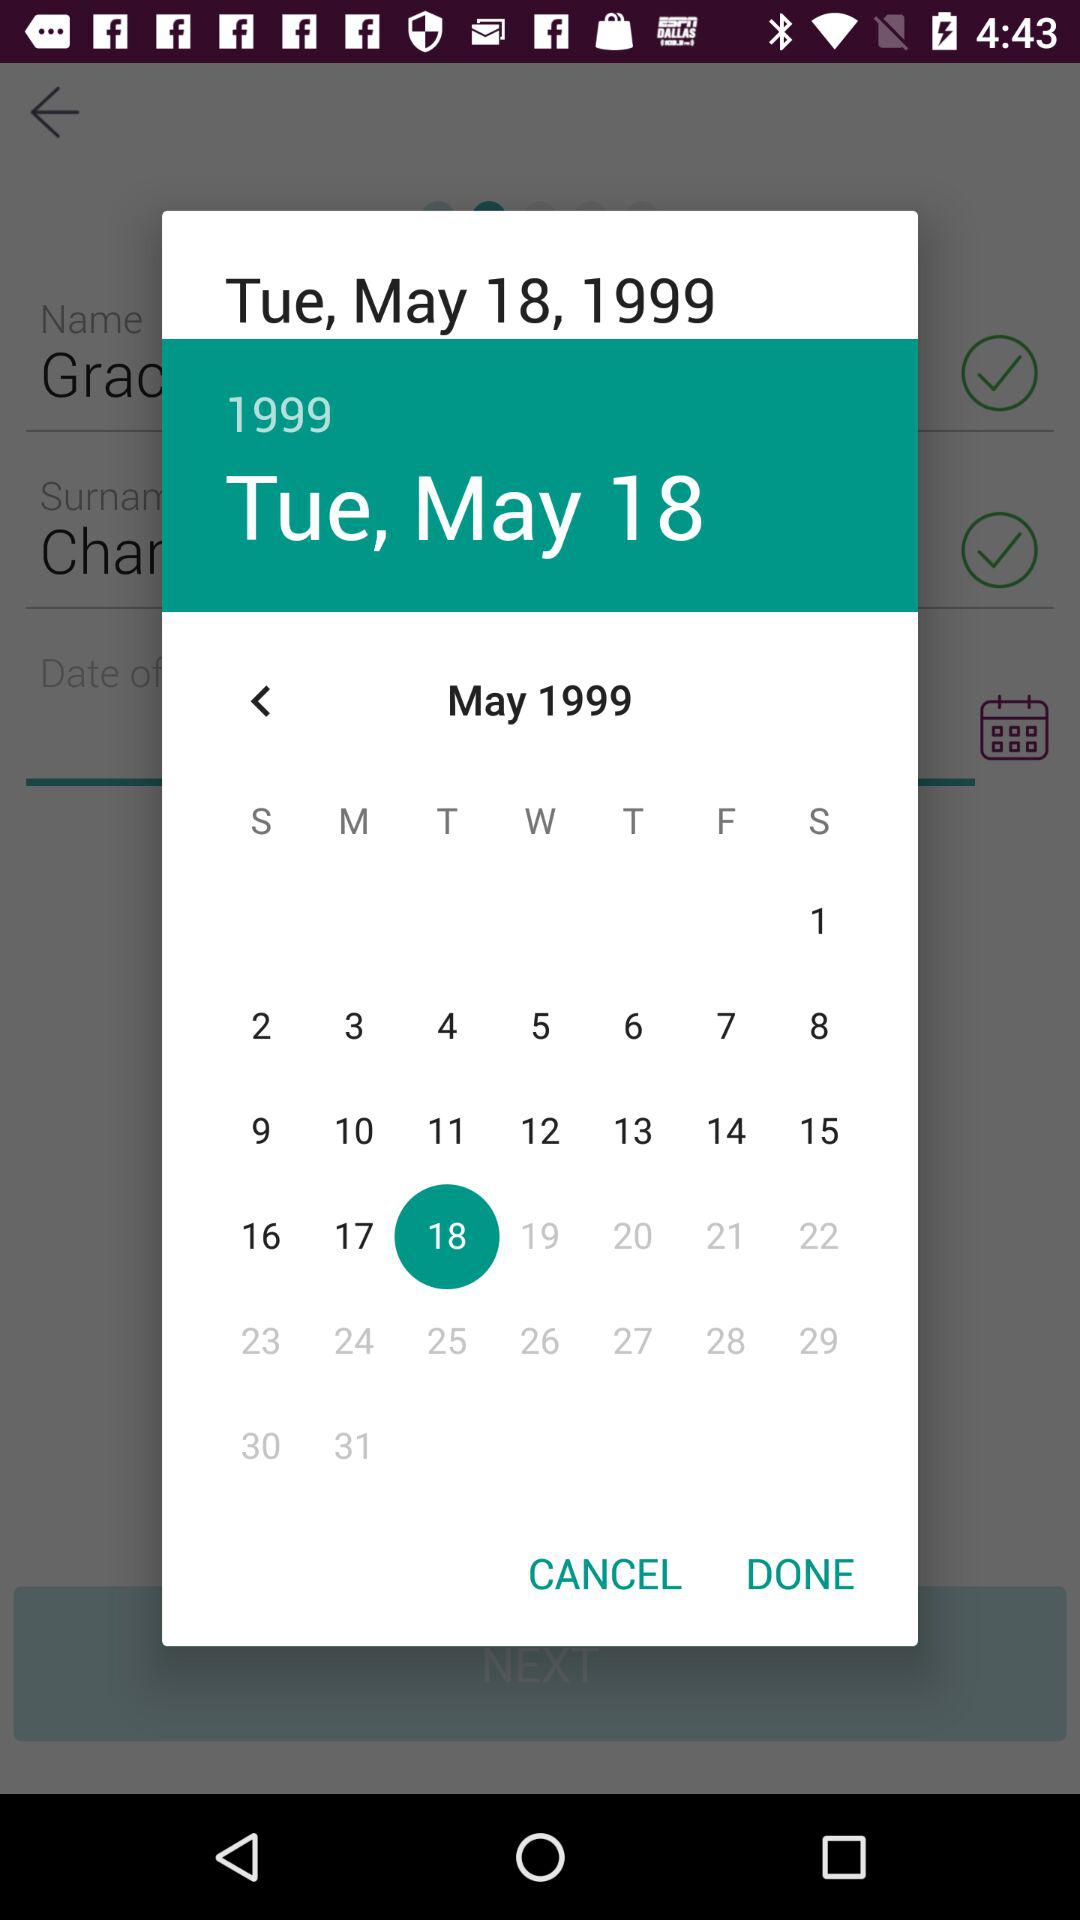What day falls on May 18, 1999? The day is Tuesday. 